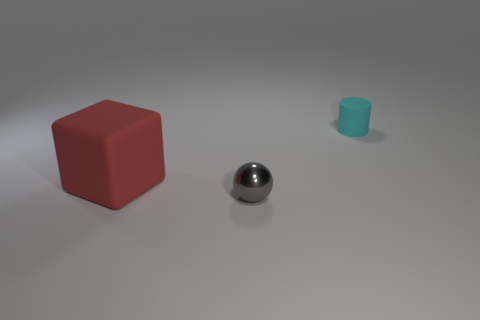Add 3 small gray spheres. How many objects exist? 6 Subtract all blocks. How many objects are left? 2 Add 1 tiny red spheres. How many tiny red spheres exist? 1 Subtract 0 cyan spheres. How many objects are left? 3 Subtract all yellow spheres. Subtract all gray cylinders. How many spheres are left? 1 Subtract all big blocks. Subtract all big red things. How many objects are left? 1 Add 1 tiny rubber objects. How many tiny rubber objects are left? 2 